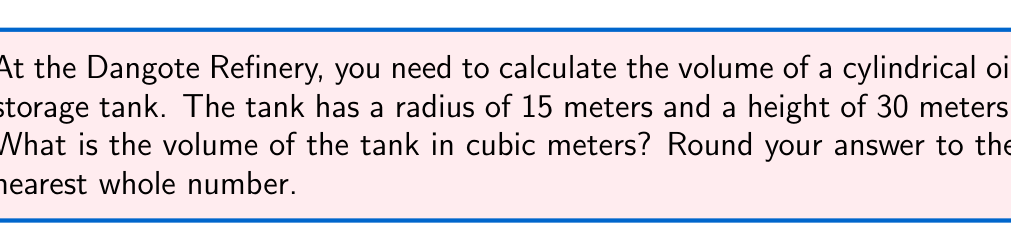Help me with this question. To calculate the volume of a cylindrical tank, we use the formula:

$$V = \pi r^2 h$$

Where:
$V$ = volume of the cylinder
$\pi$ = pi (approximately 3.14159)
$r$ = radius of the base
$h$ = height of the cylinder

Given:
$r = 15$ meters
$h = 30$ meters

Let's substitute these values into the formula:

$$V = \pi (15\text{ m})^2 (30\text{ m})$$

First, calculate $r^2$:
$$(15\text{ m})^2 = 225\text{ m}^2$$

Now, let's substitute this value:

$$V = \pi (225\text{ m}^2) (30\text{ m})$$

$$V = 6750\pi\text{ m}^3$$

Using $\pi \approx 3.14159$:

$$V \approx 6750 \times 3.14159\text{ m}^3$$

$$V \approx 21205.7325\text{ m}^3$$

Rounding to the nearest whole number:

$$V \approx 21206\text{ m}^3$$
Answer: The volume of the cylindrical oil storage tank is approximately 21,206 cubic meters. 